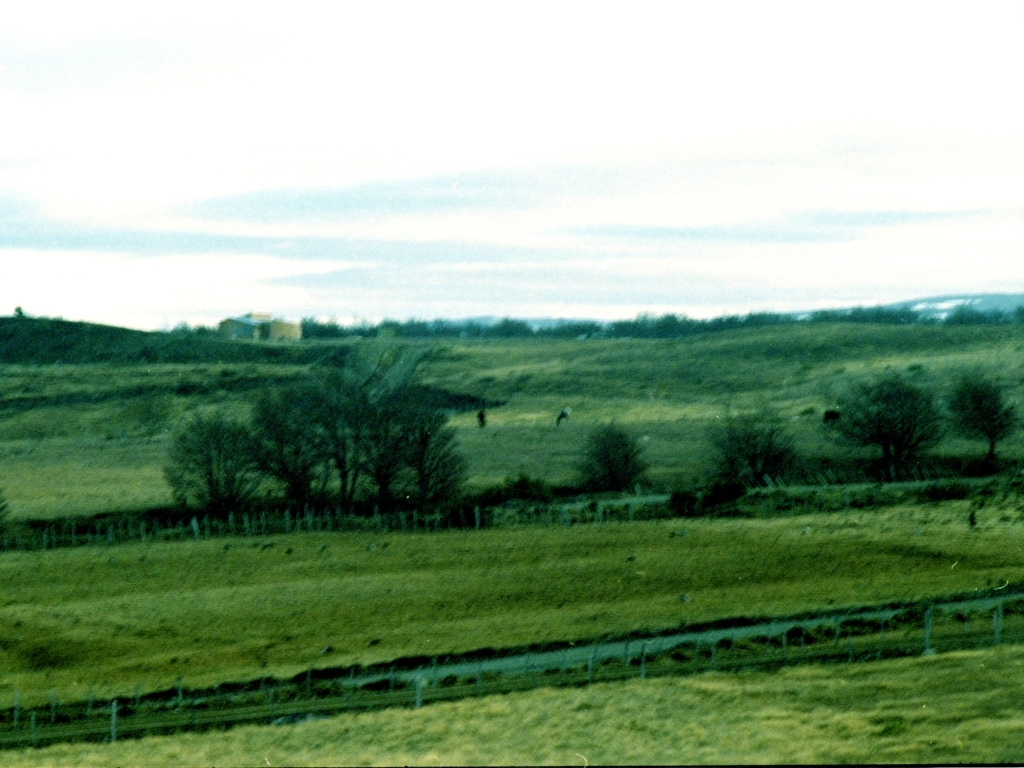Can this image tell us something about the season in which it was taken? The image suggests it might be taken in the colder months, as the trees are bare, and the grass has a faded color, lacking the vibrant green usually associated with spring or summer. However, without more definitive indicators, such as snow or blooming flowers, it's difficult to determine the season with certainty. 